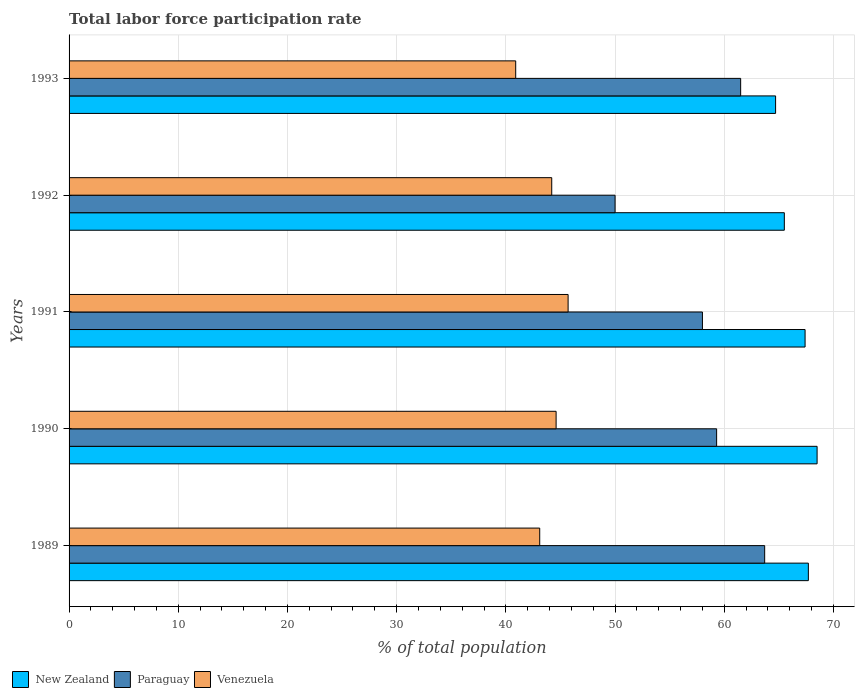How many groups of bars are there?
Your answer should be compact. 5. How many bars are there on the 2nd tick from the top?
Offer a terse response. 3. How many bars are there on the 3rd tick from the bottom?
Provide a short and direct response. 3. What is the label of the 1st group of bars from the top?
Keep it short and to the point. 1993. What is the total labor force participation rate in New Zealand in 1992?
Offer a terse response. 65.5. Across all years, what is the maximum total labor force participation rate in Paraguay?
Provide a succinct answer. 63.7. Across all years, what is the minimum total labor force participation rate in Venezuela?
Your response must be concise. 40.9. In which year was the total labor force participation rate in New Zealand minimum?
Your response must be concise. 1993. What is the total total labor force participation rate in Paraguay in the graph?
Provide a short and direct response. 292.5. What is the difference between the total labor force participation rate in Paraguay in 1991 and that in 1993?
Provide a succinct answer. -3.5. What is the difference between the total labor force participation rate in Paraguay in 1992 and the total labor force participation rate in New Zealand in 1991?
Your answer should be compact. -17.4. What is the average total labor force participation rate in Paraguay per year?
Ensure brevity in your answer.  58.5. In the year 1991, what is the difference between the total labor force participation rate in New Zealand and total labor force participation rate in Paraguay?
Offer a terse response. 9.4. In how many years, is the total labor force participation rate in Venezuela greater than 2 %?
Keep it short and to the point. 5. What is the ratio of the total labor force participation rate in Venezuela in 1990 to that in 1993?
Your answer should be very brief. 1.09. What is the difference between the highest and the second highest total labor force participation rate in Paraguay?
Offer a terse response. 2.2. What is the difference between the highest and the lowest total labor force participation rate in Paraguay?
Keep it short and to the point. 13.7. In how many years, is the total labor force participation rate in Venezuela greater than the average total labor force participation rate in Venezuela taken over all years?
Your answer should be compact. 3. What does the 2nd bar from the top in 1990 represents?
Provide a succinct answer. Paraguay. What does the 1st bar from the bottom in 1992 represents?
Your answer should be very brief. New Zealand. What is the difference between two consecutive major ticks on the X-axis?
Give a very brief answer. 10. Where does the legend appear in the graph?
Make the answer very short. Bottom left. How are the legend labels stacked?
Give a very brief answer. Horizontal. What is the title of the graph?
Provide a short and direct response. Total labor force participation rate. What is the label or title of the X-axis?
Offer a very short reply. % of total population. What is the % of total population in New Zealand in 1989?
Offer a terse response. 67.7. What is the % of total population in Paraguay in 1989?
Offer a terse response. 63.7. What is the % of total population in Venezuela in 1989?
Ensure brevity in your answer.  43.1. What is the % of total population in New Zealand in 1990?
Your answer should be compact. 68.5. What is the % of total population of Paraguay in 1990?
Make the answer very short. 59.3. What is the % of total population of Venezuela in 1990?
Make the answer very short. 44.6. What is the % of total population of New Zealand in 1991?
Offer a very short reply. 67.4. What is the % of total population in Paraguay in 1991?
Offer a very short reply. 58. What is the % of total population of Venezuela in 1991?
Provide a short and direct response. 45.7. What is the % of total population in New Zealand in 1992?
Offer a terse response. 65.5. What is the % of total population of Venezuela in 1992?
Make the answer very short. 44.2. What is the % of total population of New Zealand in 1993?
Give a very brief answer. 64.7. What is the % of total population of Paraguay in 1993?
Provide a short and direct response. 61.5. What is the % of total population of Venezuela in 1993?
Your response must be concise. 40.9. Across all years, what is the maximum % of total population in New Zealand?
Provide a succinct answer. 68.5. Across all years, what is the maximum % of total population in Paraguay?
Provide a short and direct response. 63.7. Across all years, what is the maximum % of total population in Venezuela?
Provide a succinct answer. 45.7. Across all years, what is the minimum % of total population in New Zealand?
Ensure brevity in your answer.  64.7. Across all years, what is the minimum % of total population of Paraguay?
Offer a terse response. 50. Across all years, what is the minimum % of total population of Venezuela?
Offer a terse response. 40.9. What is the total % of total population of New Zealand in the graph?
Make the answer very short. 333.8. What is the total % of total population in Paraguay in the graph?
Your answer should be very brief. 292.5. What is the total % of total population of Venezuela in the graph?
Offer a very short reply. 218.5. What is the difference between the % of total population in New Zealand in 1989 and that in 1990?
Give a very brief answer. -0.8. What is the difference between the % of total population of Venezuela in 1989 and that in 1990?
Keep it short and to the point. -1.5. What is the difference between the % of total population in Paraguay in 1989 and that in 1991?
Provide a short and direct response. 5.7. What is the difference between the % of total population in New Zealand in 1989 and that in 1992?
Make the answer very short. 2.2. What is the difference between the % of total population in Paraguay in 1989 and that in 1992?
Give a very brief answer. 13.7. What is the difference between the % of total population in Venezuela in 1989 and that in 1992?
Provide a succinct answer. -1.1. What is the difference between the % of total population of Venezuela in 1989 and that in 1993?
Make the answer very short. 2.2. What is the difference between the % of total population of New Zealand in 1990 and that in 1992?
Ensure brevity in your answer.  3. What is the difference between the % of total population in Paraguay in 1990 and that in 1992?
Make the answer very short. 9.3. What is the difference between the % of total population in Venezuela in 1990 and that in 1992?
Offer a terse response. 0.4. What is the difference between the % of total population of New Zealand in 1990 and that in 1993?
Your answer should be compact. 3.8. What is the difference between the % of total population of New Zealand in 1991 and that in 1992?
Offer a terse response. 1.9. What is the difference between the % of total population of New Zealand in 1991 and that in 1993?
Provide a short and direct response. 2.7. What is the difference between the % of total population of Paraguay in 1991 and that in 1993?
Provide a succinct answer. -3.5. What is the difference between the % of total population of Paraguay in 1992 and that in 1993?
Keep it short and to the point. -11.5. What is the difference between the % of total population in New Zealand in 1989 and the % of total population in Venezuela in 1990?
Provide a succinct answer. 23.1. What is the difference between the % of total population of New Zealand in 1989 and the % of total population of Venezuela in 1991?
Offer a very short reply. 22. What is the difference between the % of total population in Paraguay in 1989 and the % of total population in Venezuela in 1991?
Your answer should be compact. 18. What is the difference between the % of total population of New Zealand in 1989 and the % of total population of Paraguay in 1992?
Ensure brevity in your answer.  17.7. What is the difference between the % of total population in New Zealand in 1989 and the % of total population in Venezuela in 1992?
Keep it short and to the point. 23.5. What is the difference between the % of total population in Paraguay in 1989 and the % of total population in Venezuela in 1992?
Ensure brevity in your answer.  19.5. What is the difference between the % of total population of New Zealand in 1989 and the % of total population of Venezuela in 1993?
Your response must be concise. 26.8. What is the difference between the % of total population of Paraguay in 1989 and the % of total population of Venezuela in 1993?
Make the answer very short. 22.8. What is the difference between the % of total population in New Zealand in 1990 and the % of total population in Venezuela in 1991?
Offer a terse response. 22.8. What is the difference between the % of total population in New Zealand in 1990 and the % of total population in Paraguay in 1992?
Provide a succinct answer. 18.5. What is the difference between the % of total population in New Zealand in 1990 and the % of total population in Venezuela in 1992?
Your response must be concise. 24.3. What is the difference between the % of total population of Paraguay in 1990 and the % of total population of Venezuela in 1992?
Offer a very short reply. 15.1. What is the difference between the % of total population in New Zealand in 1990 and the % of total population in Paraguay in 1993?
Offer a very short reply. 7. What is the difference between the % of total population in New Zealand in 1990 and the % of total population in Venezuela in 1993?
Your answer should be compact. 27.6. What is the difference between the % of total population in New Zealand in 1991 and the % of total population in Paraguay in 1992?
Provide a short and direct response. 17.4. What is the difference between the % of total population of New Zealand in 1991 and the % of total population of Venezuela in 1992?
Offer a terse response. 23.2. What is the difference between the % of total population of Paraguay in 1991 and the % of total population of Venezuela in 1992?
Provide a short and direct response. 13.8. What is the difference between the % of total population of New Zealand in 1991 and the % of total population of Paraguay in 1993?
Give a very brief answer. 5.9. What is the difference between the % of total population in New Zealand in 1992 and the % of total population in Paraguay in 1993?
Your response must be concise. 4. What is the difference between the % of total population in New Zealand in 1992 and the % of total population in Venezuela in 1993?
Keep it short and to the point. 24.6. What is the average % of total population of New Zealand per year?
Offer a terse response. 66.76. What is the average % of total population of Paraguay per year?
Make the answer very short. 58.5. What is the average % of total population of Venezuela per year?
Ensure brevity in your answer.  43.7. In the year 1989, what is the difference between the % of total population of New Zealand and % of total population of Paraguay?
Provide a succinct answer. 4. In the year 1989, what is the difference between the % of total population in New Zealand and % of total population in Venezuela?
Your answer should be compact. 24.6. In the year 1989, what is the difference between the % of total population of Paraguay and % of total population of Venezuela?
Give a very brief answer. 20.6. In the year 1990, what is the difference between the % of total population in New Zealand and % of total population in Paraguay?
Give a very brief answer. 9.2. In the year 1990, what is the difference between the % of total population of New Zealand and % of total population of Venezuela?
Offer a terse response. 23.9. In the year 1990, what is the difference between the % of total population in Paraguay and % of total population in Venezuela?
Your response must be concise. 14.7. In the year 1991, what is the difference between the % of total population of New Zealand and % of total population of Venezuela?
Your answer should be very brief. 21.7. In the year 1992, what is the difference between the % of total population of New Zealand and % of total population of Paraguay?
Keep it short and to the point. 15.5. In the year 1992, what is the difference between the % of total population of New Zealand and % of total population of Venezuela?
Offer a terse response. 21.3. In the year 1993, what is the difference between the % of total population in New Zealand and % of total population in Paraguay?
Provide a succinct answer. 3.2. In the year 1993, what is the difference between the % of total population in New Zealand and % of total population in Venezuela?
Make the answer very short. 23.8. In the year 1993, what is the difference between the % of total population of Paraguay and % of total population of Venezuela?
Your answer should be very brief. 20.6. What is the ratio of the % of total population of New Zealand in 1989 to that in 1990?
Give a very brief answer. 0.99. What is the ratio of the % of total population in Paraguay in 1989 to that in 1990?
Offer a terse response. 1.07. What is the ratio of the % of total population of Venezuela in 1989 to that in 1990?
Give a very brief answer. 0.97. What is the ratio of the % of total population in Paraguay in 1989 to that in 1991?
Offer a very short reply. 1.1. What is the ratio of the % of total population in Venezuela in 1989 to that in 1991?
Provide a succinct answer. 0.94. What is the ratio of the % of total population of New Zealand in 1989 to that in 1992?
Your answer should be very brief. 1.03. What is the ratio of the % of total population in Paraguay in 1989 to that in 1992?
Ensure brevity in your answer.  1.27. What is the ratio of the % of total population of Venezuela in 1989 to that in 1992?
Your response must be concise. 0.98. What is the ratio of the % of total population in New Zealand in 1989 to that in 1993?
Ensure brevity in your answer.  1.05. What is the ratio of the % of total population of Paraguay in 1989 to that in 1993?
Give a very brief answer. 1.04. What is the ratio of the % of total population of Venezuela in 1989 to that in 1993?
Your answer should be compact. 1.05. What is the ratio of the % of total population of New Zealand in 1990 to that in 1991?
Make the answer very short. 1.02. What is the ratio of the % of total population in Paraguay in 1990 to that in 1991?
Your response must be concise. 1.02. What is the ratio of the % of total population of Venezuela in 1990 to that in 1991?
Offer a very short reply. 0.98. What is the ratio of the % of total population in New Zealand in 1990 to that in 1992?
Offer a terse response. 1.05. What is the ratio of the % of total population in Paraguay in 1990 to that in 1992?
Provide a short and direct response. 1.19. What is the ratio of the % of total population of Venezuela in 1990 to that in 1992?
Offer a terse response. 1.01. What is the ratio of the % of total population of New Zealand in 1990 to that in 1993?
Make the answer very short. 1.06. What is the ratio of the % of total population in Paraguay in 1990 to that in 1993?
Offer a very short reply. 0.96. What is the ratio of the % of total population of Venezuela in 1990 to that in 1993?
Offer a very short reply. 1.09. What is the ratio of the % of total population of Paraguay in 1991 to that in 1992?
Your answer should be very brief. 1.16. What is the ratio of the % of total population of Venezuela in 1991 to that in 1992?
Give a very brief answer. 1.03. What is the ratio of the % of total population in New Zealand in 1991 to that in 1993?
Provide a succinct answer. 1.04. What is the ratio of the % of total population in Paraguay in 1991 to that in 1993?
Provide a succinct answer. 0.94. What is the ratio of the % of total population in Venezuela in 1991 to that in 1993?
Your response must be concise. 1.12. What is the ratio of the % of total population of New Zealand in 1992 to that in 1993?
Provide a short and direct response. 1.01. What is the ratio of the % of total population of Paraguay in 1992 to that in 1993?
Offer a very short reply. 0.81. What is the ratio of the % of total population of Venezuela in 1992 to that in 1993?
Your answer should be compact. 1.08. What is the difference between the highest and the lowest % of total population in New Zealand?
Your answer should be very brief. 3.8. What is the difference between the highest and the lowest % of total population in Paraguay?
Your answer should be very brief. 13.7. 